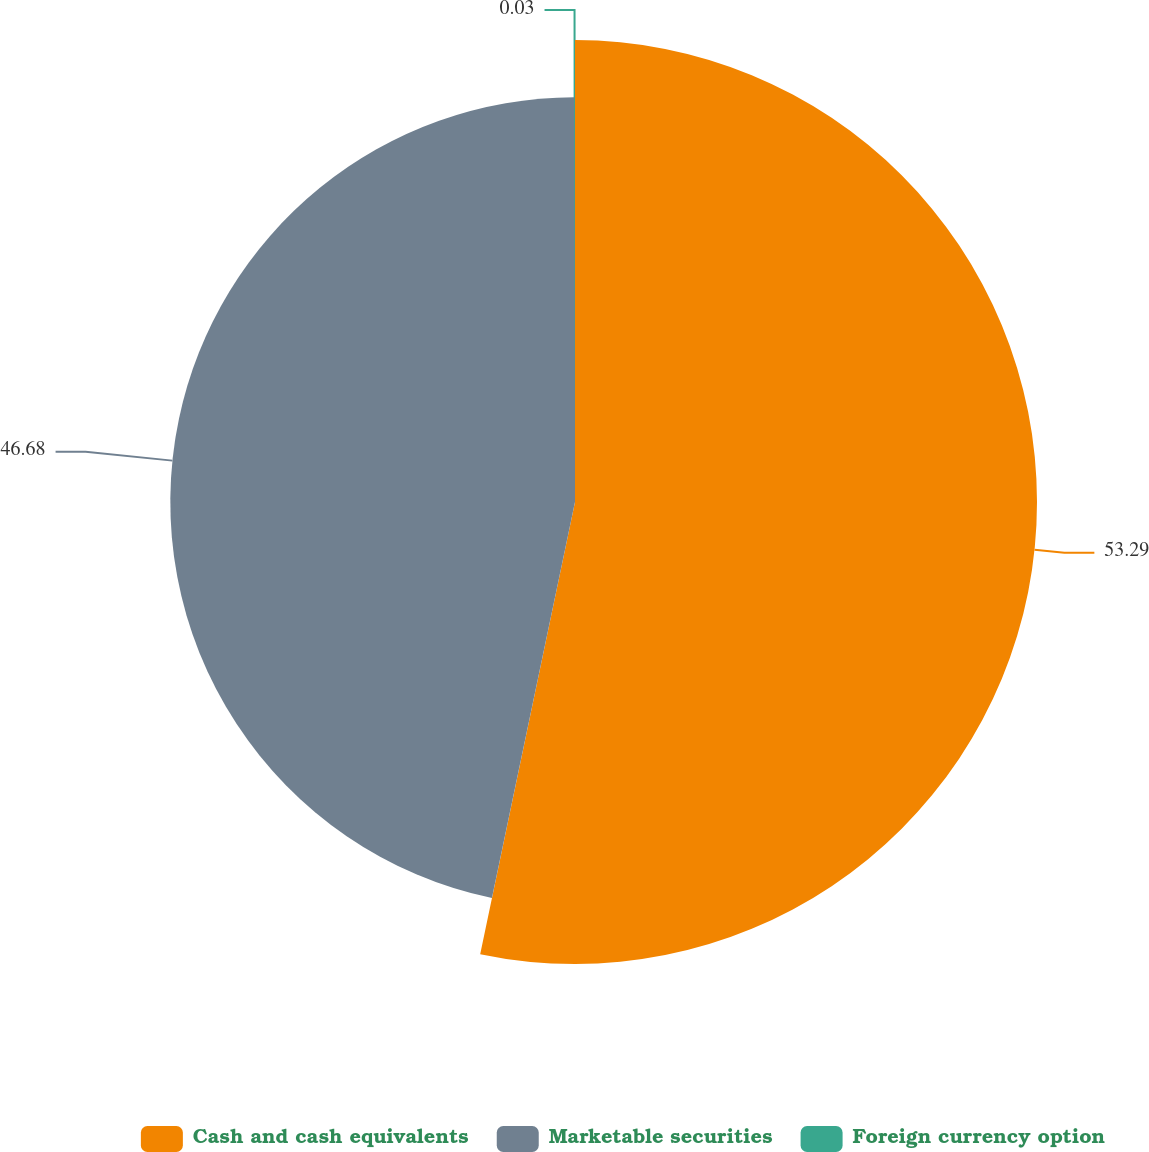Convert chart to OTSL. <chart><loc_0><loc_0><loc_500><loc_500><pie_chart><fcel>Cash and cash equivalents<fcel>Marketable securities<fcel>Foreign currency option<nl><fcel>53.29%<fcel>46.68%<fcel>0.03%<nl></chart> 